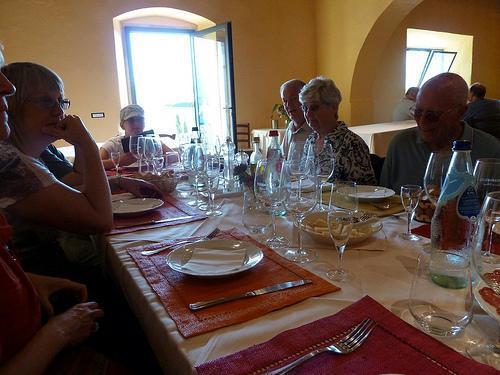How many people are at the table?
Give a very brief answer. 6. 